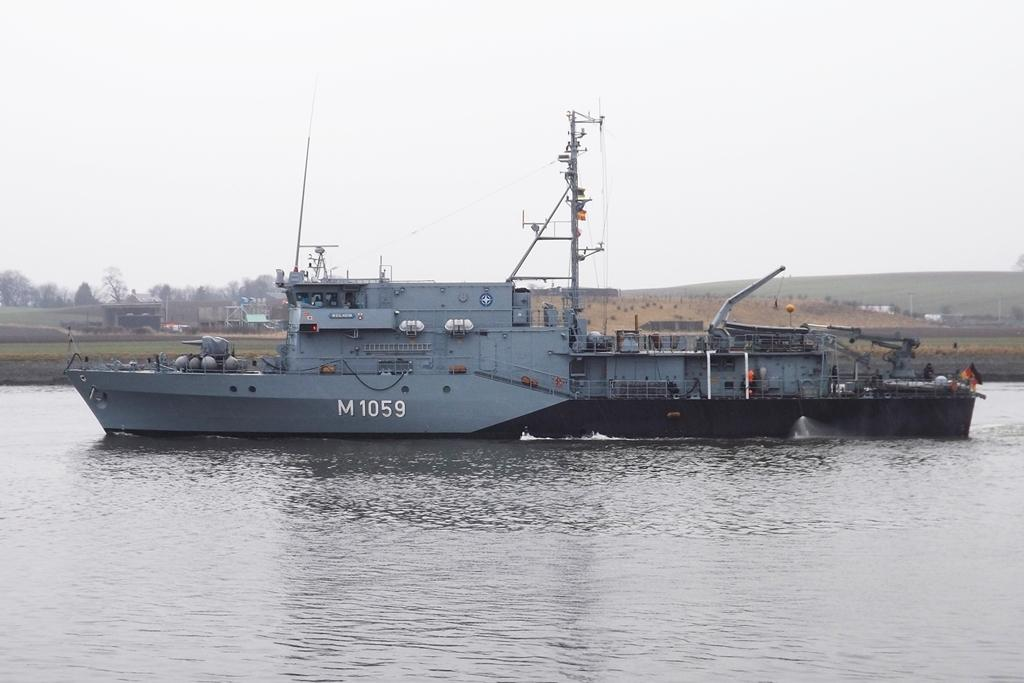What is the main subject of the image? The main subject of the image is a ship. Where is the ship located in the image? The ship is on the water in the image. What can be seen on the ship? There are objects on the ship. What is visible in the background of the image? The sky, trees, grass, and other objects are visible in the background of the image. What type of bomb can be seen falling from the sky in the image? There is no bomb present in the image; it features a ship on the water with a background of sky, trees, grass, and other objects. What is the name of the downtown area visible in the image? There is no downtown area visible in the image; it features a ship on the water with a background of sky, trees, grass, and other objects. 